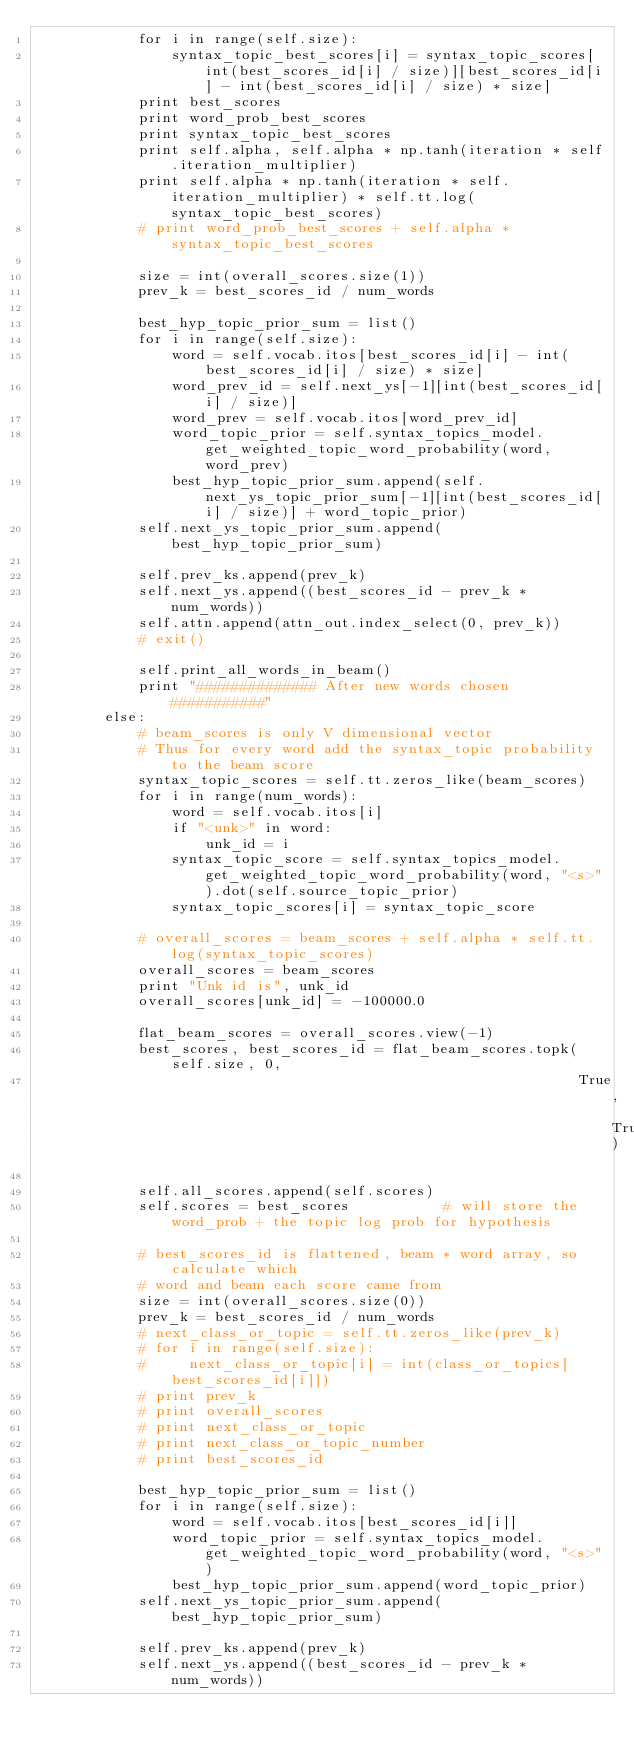<code> <loc_0><loc_0><loc_500><loc_500><_Python_>            for i in range(self.size):
                syntax_topic_best_scores[i] = syntax_topic_scores[int(best_scores_id[i] / size)][best_scores_id[i] - int(best_scores_id[i] / size) * size]
            print best_scores
            print word_prob_best_scores
            print syntax_topic_best_scores
            print self.alpha, self.alpha * np.tanh(iteration * self.iteration_multiplier)
            print self.alpha * np.tanh(iteration * self.iteration_multiplier) * self.tt.log(syntax_topic_best_scores)
            # print word_prob_best_scores + self.alpha * syntax_topic_best_scores

            size = int(overall_scores.size(1))
            prev_k = best_scores_id / num_words

            best_hyp_topic_prior_sum = list()
            for i in range(self.size):
                word = self.vocab.itos[best_scores_id[i] - int(best_scores_id[i] / size) * size]
                word_prev_id = self.next_ys[-1][int(best_scores_id[i] / size)]
                word_prev = self.vocab.itos[word_prev_id]
                word_topic_prior = self.syntax_topics_model.get_weighted_topic_word_probability(word, word_prev)
                best_hyp_topic_prior_sum.append(self.next_ys_topic_prior_sum[-1][int(best_scores_id[i] / size)] + word_topic_prior)
            self.next_ys_topic_prior_sum.append(best_hyp_topic_prior_sum)

            self.prev_ks.append(prev_k)
            self.next_ys.append((best_scores_id - prev_k * num_words))
            self.attn.append(attn_out.index_select(0, prev_k))
            # exit()

            self.print_all_words_in_beam()
            print "############## After new words chosen ###########"
        else:
            # beam_scores is only V dimensional vector
            # Thus for every word add the syntax_topic probability to the beam score
            syntax_topic_scores = self.tt.zeros_like(beam_scores)
            for i in range(num_words):
                word = self.vocab.itos[i]
                if "<unk>" in word:
                    unk_id = i
                syntax_topic_score = self.syntax_topics_model.get_weighted_topic_word_probability(word, "<s>").dot(self.source_topic_prior)
                syntax_topic_scores[i] = syntax_topic_score

            # overall_scores = beam_scores + self.alpha * self.tt.log(syntax_topic_scores)
            overall_scores = beam_scores
            print "Unk id is", unk_id
            overall_scores[unk_id] = -100000.0

            flat_beam_scores = overall_scores.view(-1)
            best_scores, best_scores_id = flat_beam_scores.topk(self.size, 0,
                                                                True, True)

            self.all_scores.append(self.scores)
            self.scores = best_scores           # will store the word_prob + the topic log prob for hypothesis

            # best_scores_id is flattened, beam * word array, so calculate which
            # word and beam each score came from
            size = int(overall_scores.size(0))
            prev_k = best_scores_id / num_words
            # next_class_or_topic = self.tt.zeros_like(prev_k)
            # for i in range(self.size):
            #     next_class_or_topic[i] = int(class_or_topics[best_scores_id[i]])
            # print prev_k
            # print overall_scores
            # print next_class_or_topic
            # print next_class_or_topic_number
            # print best_scores_id

            best_hyp_topic_prior_sum = list()
            for i in range(self.size):
                word = self.vocab.itos[best_scores_id[i]]
                word_topic_prior = self.syntax_topics_model.get_weighted_topic_word_probability(word, "<s>")
                best_hyp_topic_prior_sum.append(word_topic_prior)
            self.next_ys_topic_prior_sum.append(best_hyp_topic_prior_sum)

            self.prev_ks.append(prev_k)
            self.next_ys.append((best_scores_id - prev_k * num_words))</code> 